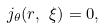<formula> <loc_0><loc_0><loc_500><loc_500>j _ { \theta } ( r , \ \xi ) = 0 ,</formula> 